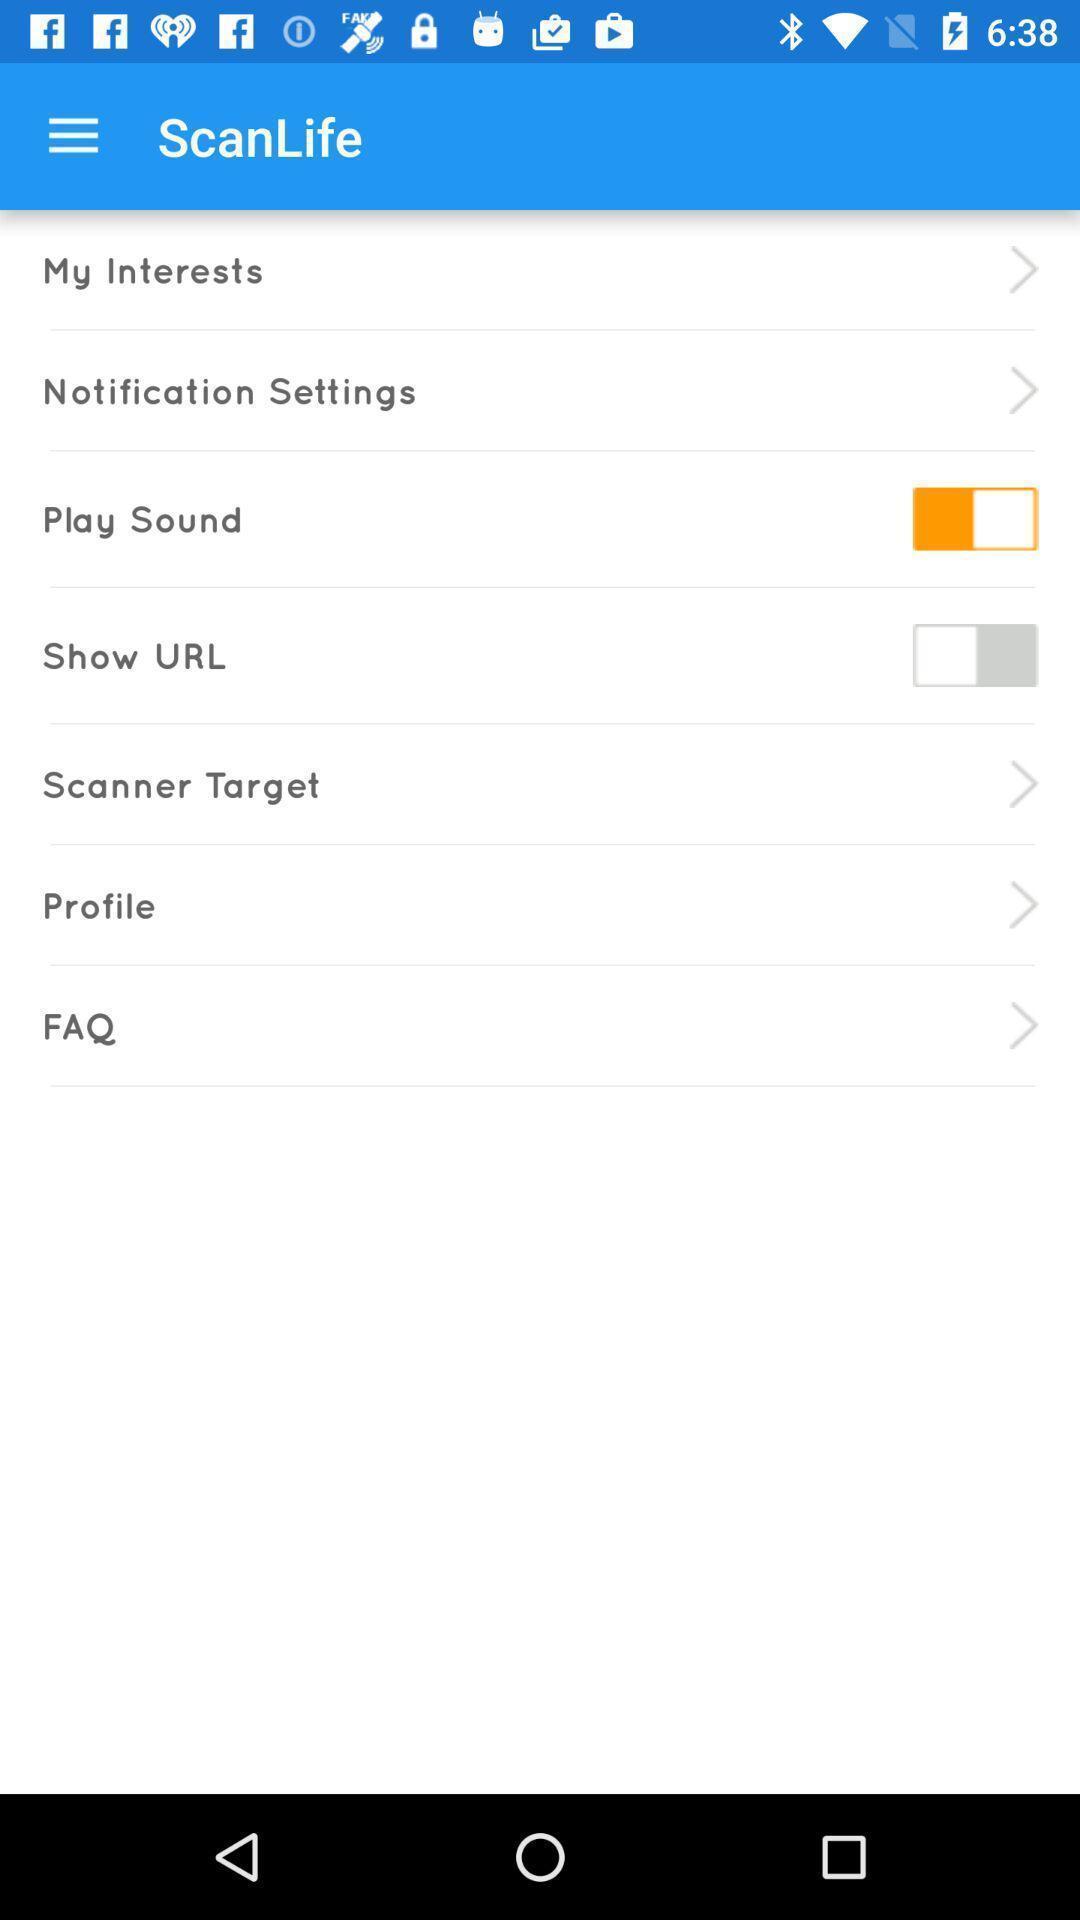Tell me about the visual elements in this screen capture. Showing various options in scanning app. 